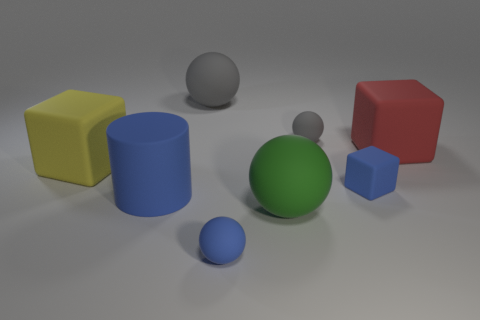There is a red thing that is the same shape as the big yellow matte thing; what is its size?
Provide a succinct answer. Large. There is a gray object in front of the big gray rubber sphere; does it have the same shape as the large green object?
Provide a succinct answer. Yes. What is the color of the matte block to the left of the big gray matte object?
Your answer should be very brief. Yellow. How many other things are there of the same size as the red rubber block?
Ensure brevity in your answer.  4. Is there any other thing that is the same shape as the big green rubber object?
Make the answer very short. Yes. Are there an equal number of red rubber blocks in front of the small blue block and large red shiny blocks?
Keep it short and to the point. Yes. How many blue cylinders are made of the same material as the big green object?
Your answer should be compact. 1. What color is the cylinder that is made of the same material as the large yellow object?
Offer a very short reply. Blue. Is the shape of the yellow rubber thing the same as the large red rubber thing?
Your answer should be compact. Yes. There is a large ball that is in front of the gray matte ball on the right side of the tiny blue sphere; is there a tiny rubber thing behind it?
Make the answer very short. Yes. 